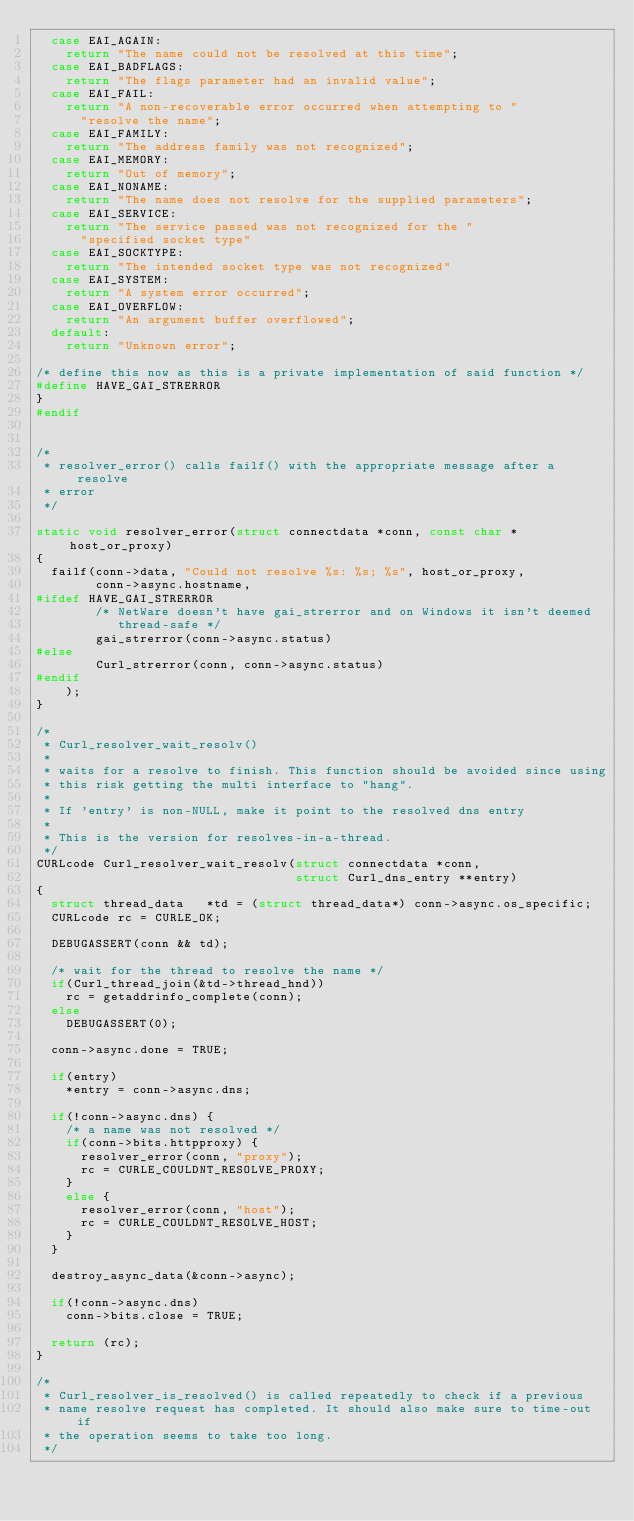Convert code to text. <code><loc_0><loc_0><loc_500><loc_500><_C_>  case EAI_AGAIN:
    return "The name could not be resolved at this time";
  case EAI_BADFLAGS:
    return "The flags parameter had an invalid value";
  case EAI_FAIL:
    return "A non-recoverable error occurred when attempting to "
      "resolve the name";
  case EAI_FAMILY:
    return "The address family was not recognized";
  case EAI_MEMORY:
    return "Out of memory";
  case EAI_NONAME:
    return "The name does not resolve for the supplied parameters";
  case EAI_SERVICE:
    return "The service passed was not recognized for the "
      "specified socket type"
  case EAI_SOCKTYPE:
    return "The intended socket type was not recognized"
  case EAI_SYSTEM:
    return "A system error occurred";
  case EAI_OVERFLOW:
    return "An argument buffer overflowed";
  default:
    return "Unknown error";

/* define this now as this is a private implementation of said function */
#define HAVE_GAI_STRERROR
}
#endif


/*
 * resolver_error() calls failf() with the appropriate message after a resolve
 * error
 */

static void resolver_error(struct connectdata *conn, const char *host_or_proxy)
{
  failf(conn->data, "Could not resolve %s: %s; %s", host_or_proxy,
        conn->async.hostname,
#ifdef HAVE_GAI_STRERROR
        /* NetWare doesn't have gai_strerror and on Windows it isn't deemed
           thread-safe */
        gai_strerror(conn->async.status)
#else
        Curl_strerror(conn, conn->async.status)
#endif
    );
}

/*
 * Curl_resolver_wait_resolv()
 *
 * waits for a resolve to finish. This function should be avoided since using
 * this risk getting the multi interface to "hang".
 *
 * If 'entry' is non-NULL, make it point to the resolved dns entry
 *
 * This is the version for resolves-in-a-thread.
 */
CURLcode Curl_resolver_wait_resolv(struct connectdata *conn,
                                   struct Curl_dns_entry **entry)
{
  struct thread_data   *td = (struct thread_data*) conn->async.os_specific;
  CURLcode rc = CURLE_OK;

  DEBUGASSERT(conn && td);

  /* wait for the thread to resolve the name */
  if(Curl_thread_join(&td->thread_hnd))
    rc = getaddrinfo_complete(conn);
  else
    DEBUGASSERT(0);

  conn->async.done = TRUE;

  if(entry)
    *entry = conn->async.dns;

  if(!conn->async.dns) {
    /* a name was not resolved */
    if(conn->bits.httpproxy) {
      resolver_error(conn, "proxy");
      rc = CURLE_COULDNT_RESOLVE_PROXY;
    }
    else {
      resolver_error(conn, "host");
      rc = CURLE_COULDNT_RESOLVE_HOST;
    }
  }

  destroy_async_data(&conn->async);

  if(!conn->async.dns)
    conn->bits.close = TRUE;

  return (rc);
}

/*
 * Curl_resolver_is_resolved() is called repeatedly to check if a previous
 * name resolve request has completed. It should also make sure to time-out if
 * the operation seems to take too long.
 */</code> 